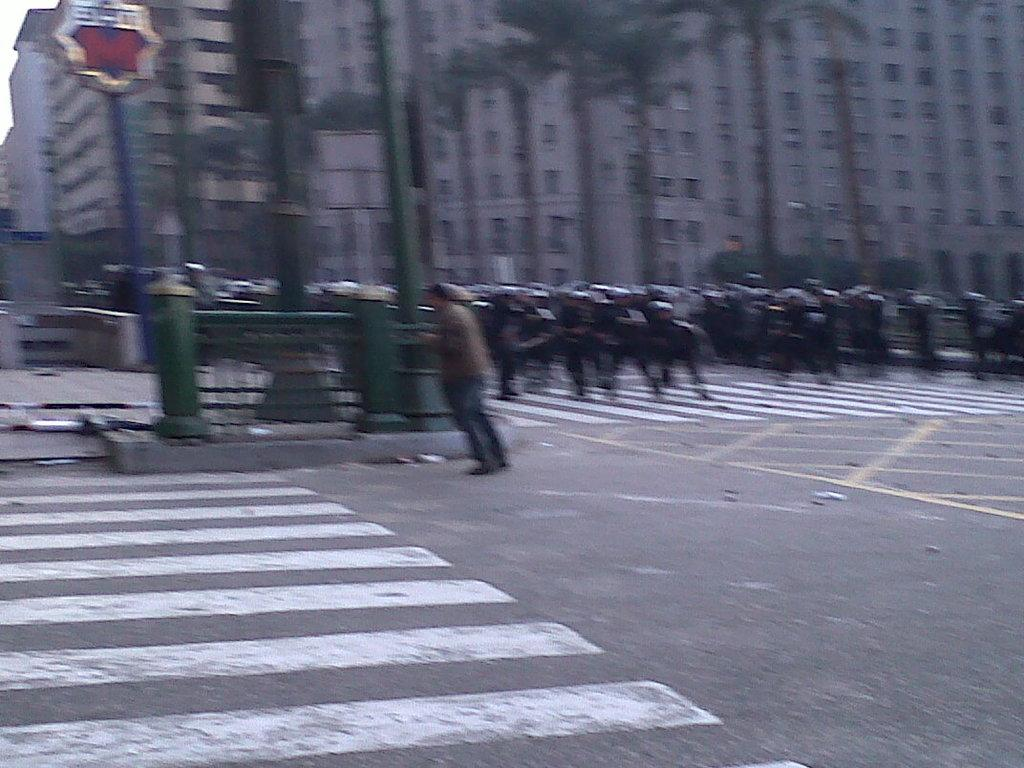What is happening on the road in the image? There are persons on the road in the image. What can be seen in the background of the image? There are trees and buildings in the background. How much debt do the persons on the road have in the image? There is no information about debt in the image, as it only shows persons on the road and the background. Is there a woman among the persons on the road in the image? The image does not provide information about the gender of the persons on the road, so it cannot be determined if there is a woman present. 